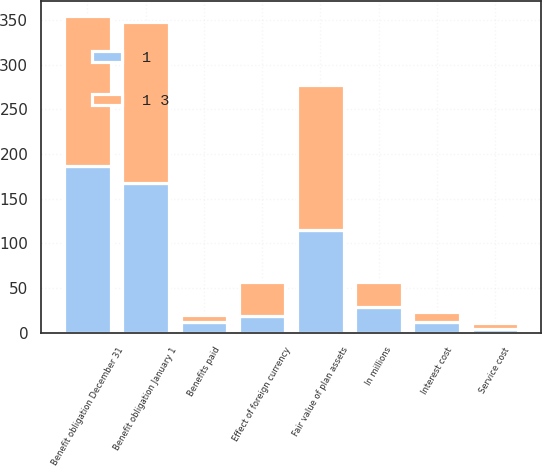Convert chart. <chart><loc_0><loc_0><loc_500><loc_500><stacked_bar_chart><ecel><fcel>In millions<fcel>Benefit obligation January 1<fcel>Service cost<fcel>Interest cost<fcel>Benefits paid<fcel>Effect of foreign currency<fcel>Benefit obligation December 31<fcel>Fair value of plan assets<nl><fcel>1<fcel>28.5<fcel>168<fcel>4<fcel>12<fcel>12<fcel>19<fcel>186<fcel>115<nl><fcel>1 3<fcel>28.5<fcel>180<fcel>7<fcel>11<fcel>8<fcel>38<fcel>168<fcel>162<nl></chart> 